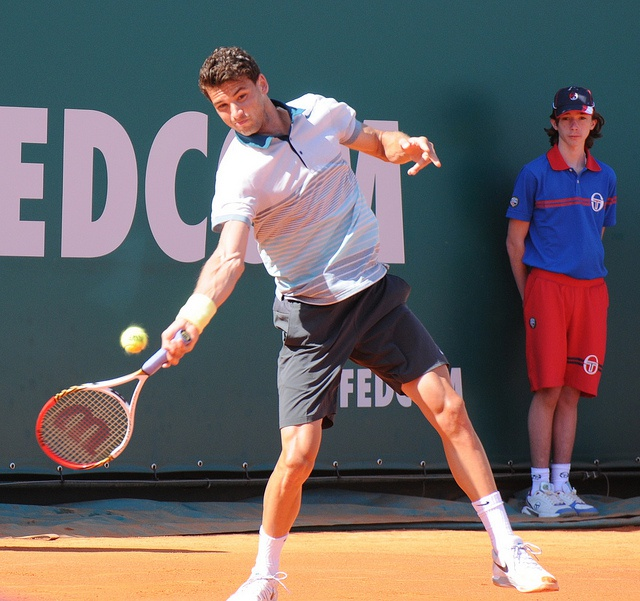Describe the objects in this image and their specific colors. I can see people in teal, white, black, darkgray, and lightpink tones, people in teal, brown, and darkblue tones, tennis racket in teal, brown, gray, white, and salmon tones, and sports ball in teal, ivory, khaki, and orange tones in this image. 